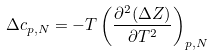Convert formula to latex. <formula><loc_0><loc_0><loc_500><loc_500>\Delta c _ { p , N } = - T \left ( \frac { \partial ^ { 2 } ( \Delta Z ) } { \partial T ^ { 2 } } \right ) _ { p , N }</formula> 